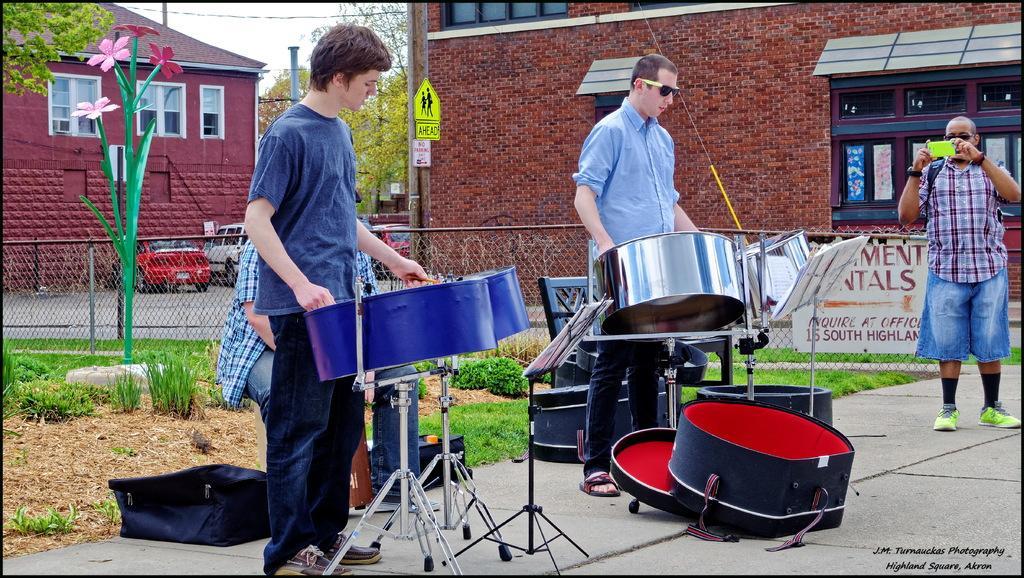In one or two sentences, can you explain what this image depicts? In this picture there are two people those who are playing the drums and the person who is at the right side of the image is taking the video, there is a house at the right side of the image and there are some trees around the area of the image. 